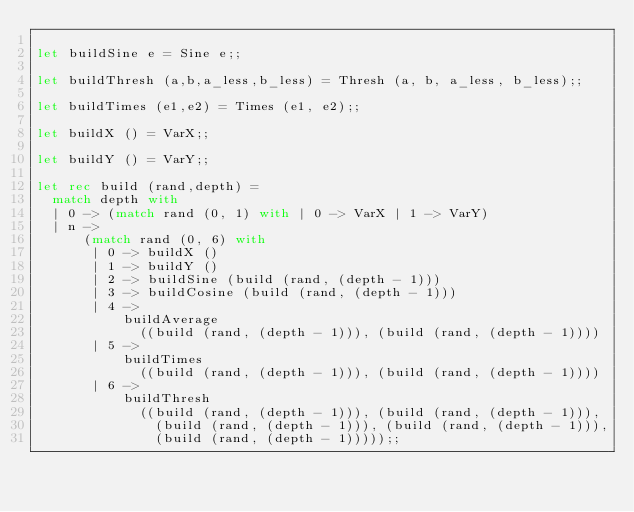Convert code to text. <code><loc_0><loc_0><loc_500><loc_500><_OCaml_>
let buildSine e = Sine e;;

let buildThresh (a,b,a_less,b_less) = Thresh (a, b, a_less, b_less);;

let buildTimes (e1,e2) = Times (e1, e2);;

let buildX () = VarX;;

let buildY () = VarY;;

let rec build (rand,depth) =
  match depth with
  | 0 -> (match rand (0, 1) with | 0 -> VarX | 1 -> VarY)
  | n ->
      (match rand (0, 6) with
       | 0 -> buildX ()
       | 1 -> buildY ()
       | 2 -> buildSine (build (rand, (depth - 1)))
       | 3 -> buildCosine (build (rand, (depth - 1)))
       | 4 ->
           buildAverage
             ((build (rand, (depth - 1))), (build (rand, (depth - 1))))
       | 5 ->
           buildTimes
             ((build (rand, (depth - 1))), (build (rand, (depth - 1))))
       | 6 ->
           buildThresh
             ((build (rand, (depth - 1))), (build (rand, (depth - 1))),
               (build (rand, (depth - 1))), (build (rand, (depth - 1))),
               (build (rand, (depth - 1)))));;
</code> 